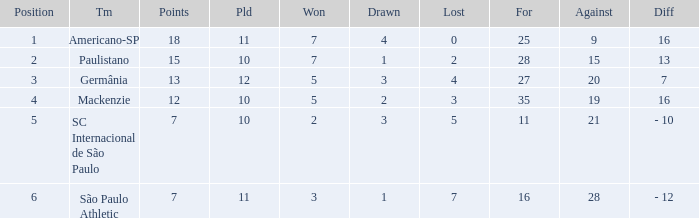Name the points for paulistano 15.0. 